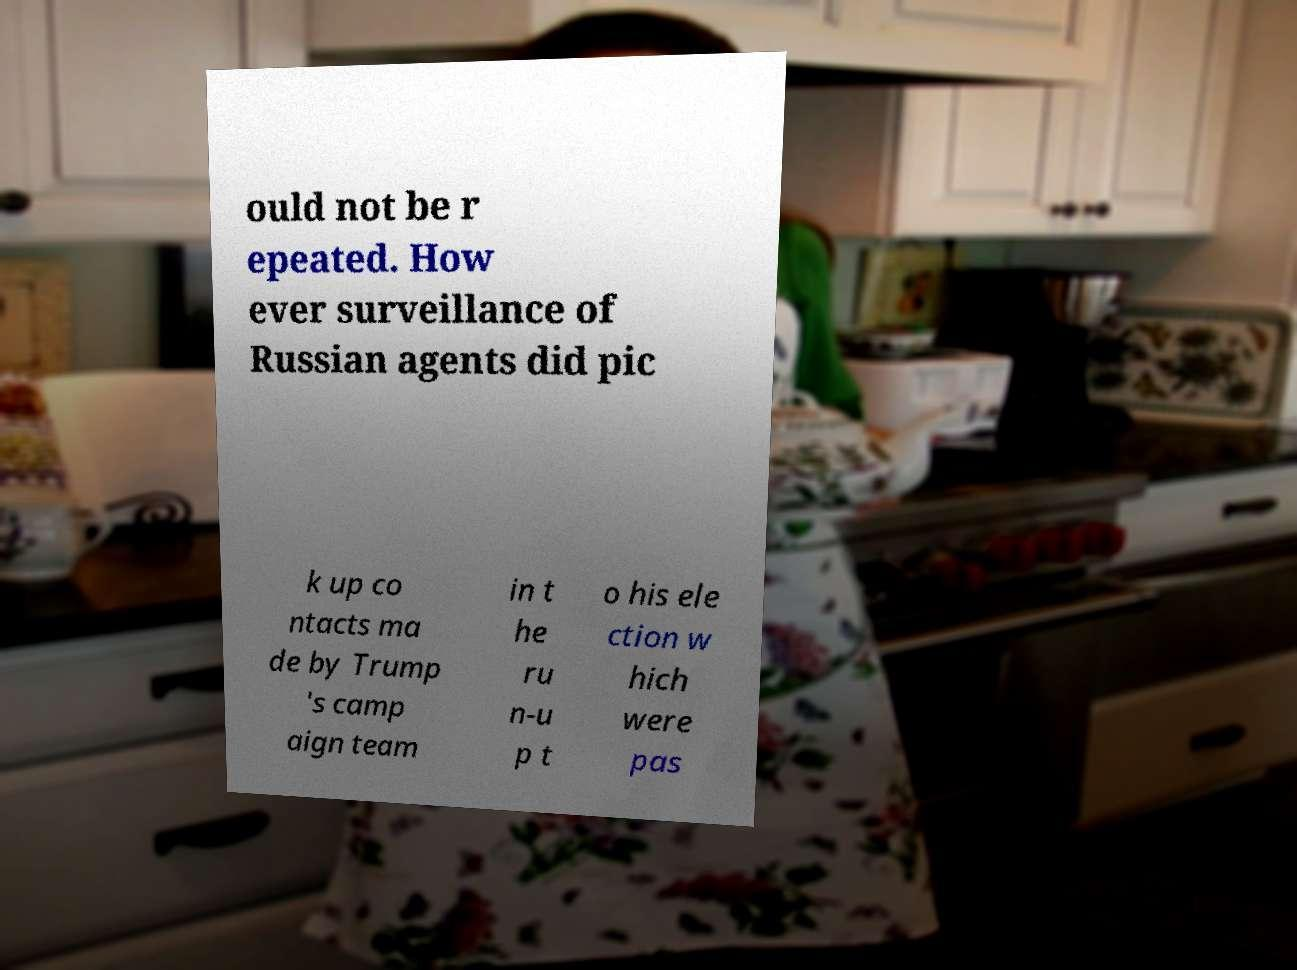Please identify and transcribe the text found in this image. ould not be r epeated. How ever surveillance of Russian agents did pic k up co ntacts ma de by Trump 's camp aign team in t he ru n-u p t o his ele ction w hich were pas 